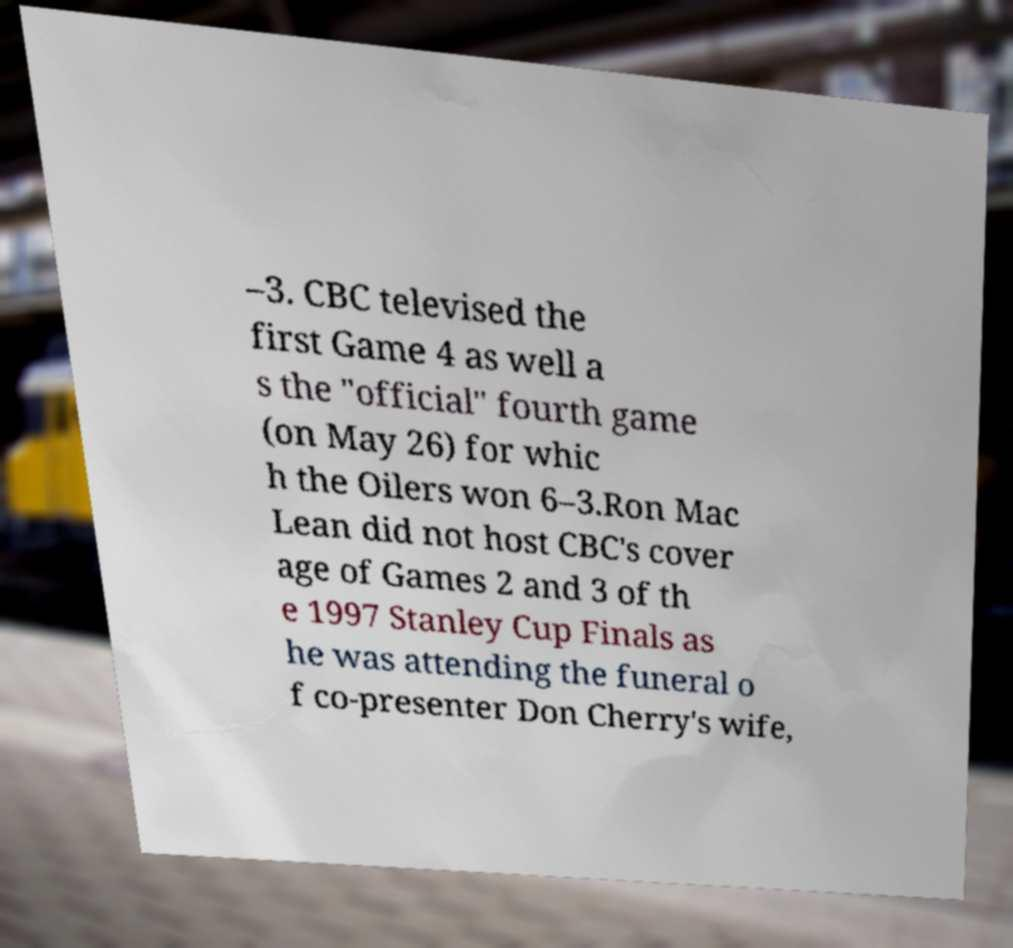Could you assist in decoding the text presented in this image and type it out clearly? –3. CBC televised the first Game 4 as well a s the "official" fourth game (on May 26) for whic h the Oilers won 6–3.Ron Mac Lean did not host CBC's cover age of Games 2 and 3 of th e 1997 Stanley Cup Finals as he was attending the funeral o f co-presenter Don Cherry's wife, 